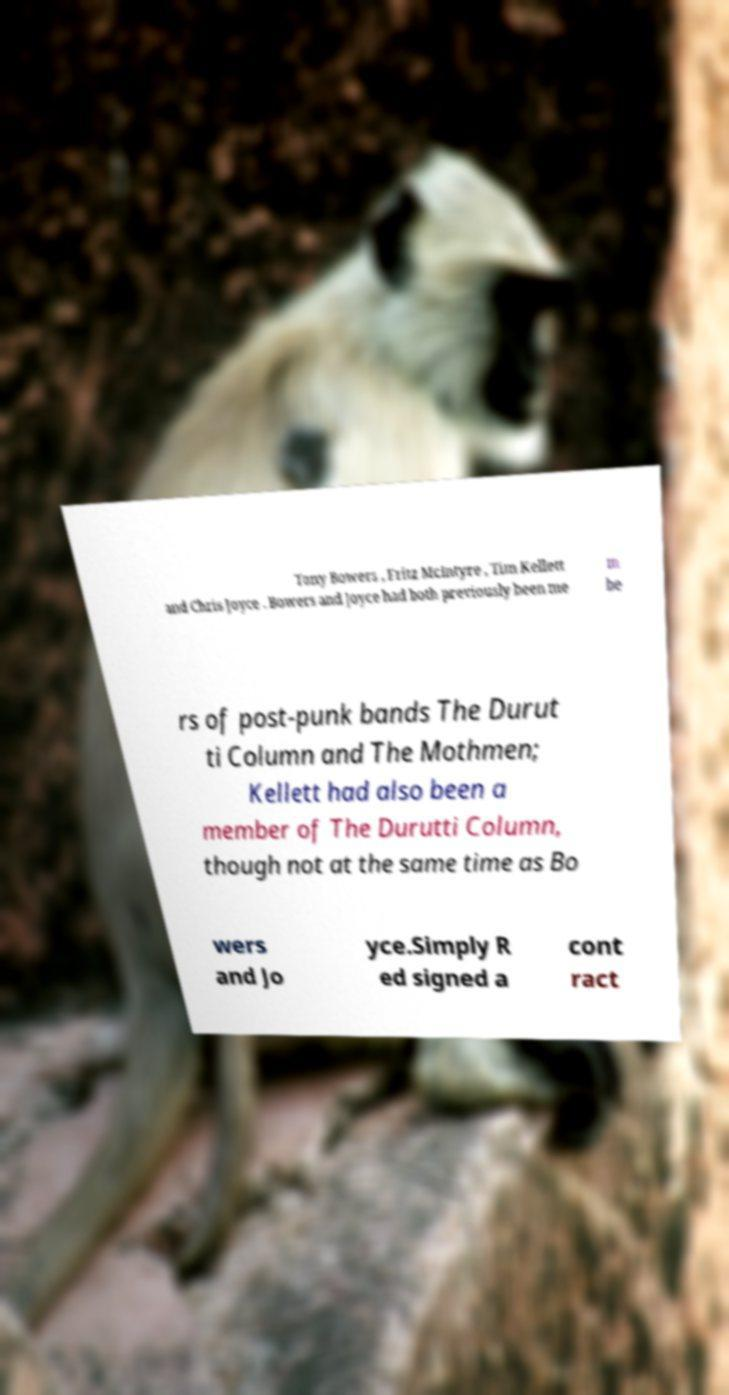What messages or text are displayed in this image? I need them in a readable, typed format. Tony Bowers , Fritz McIntyre , Tim Kellett and Chris Joyce . Bowers and Joyce had both previously been me m be rs of post-punk bands The Durut ti Column and The Mothmen; Kellett had also been a member of The Durutti Column, though not at the same time as Bo wers and Jo yce.Simply R ed signed a cont ract 